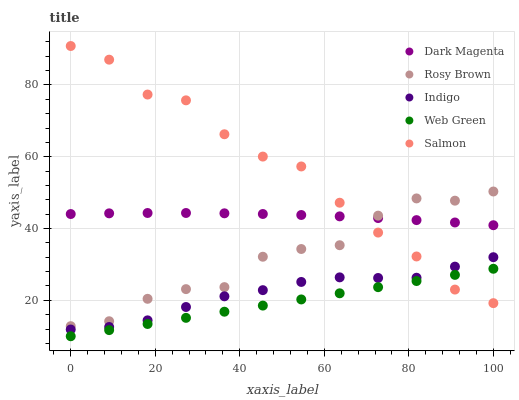Does Web Green have the minimum area under the curve?
Answer yes or no. Yes. Does Salmon have the maximum area under the curve?
Answer yes or no. Yes. Does Rosy Brown have the minimum area under the curve?
Answer yes or no. No. Does Rosy Brown have the maximum area under the curve?
Answer yes or no. No. Is Web Green the smoothest?
Answer yes or no. Yes. Is Salmon the roughest?
Answer yes or no. Yes. Is Rosy Brown the smoothest?
Answer yes or no. No. Is Rosy Brown the roughest?
Answer yes or no. No. Does Web Green have the lowest value?
Answer yes or no. Yes. Does Rosy Brown have the lowest value?
Answer yes or no. No. Does Salmon have the highest value?
Answer yes or no. Yes. Does Rosy Brown have the highest value?
Answer yes or no. No. Is Web Green less than Dark Magenta?
Answer yes or no. Yes. Is Dark Magenta greater than Web Green?
Answer yes or no. Yes. Does Dark Magenta intersect Salmon?
Answer yes or no. Yes. Is Dark Magenta less than Salmon?
Answer yes or no. No. Is Dark Magenta greater than Salmon?
Answer yes or no. No. Does Web Green intersect Dark Magenta?
Answer yes or no. No. 